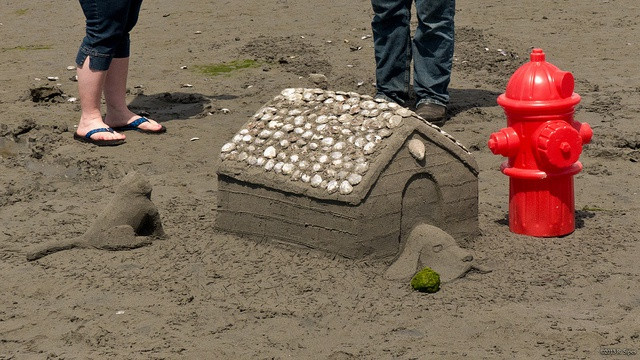Describe the objects in this image and their specific colors. I can see fire hydrant in gray, red, maroon, and salmon tones, people in gray, black, purple, and darkblue tones, and people in gray, black, brown, lightpink, and maroon tones in this image. 